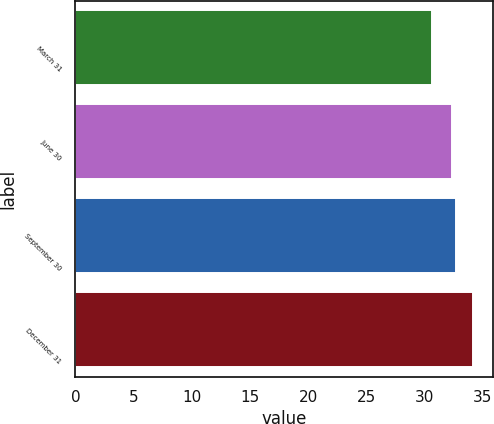Convert chart to OTSL. <chart><loc_0><loc_0><loc_500><loc_500><bar_chart><fcel>March 31<fcel>June 30<fcel>September 30<fcel>December 31<nl><fcel>30.64<fcel>32.34<fcel>32.69<fcel>34.18<nl></chart> 